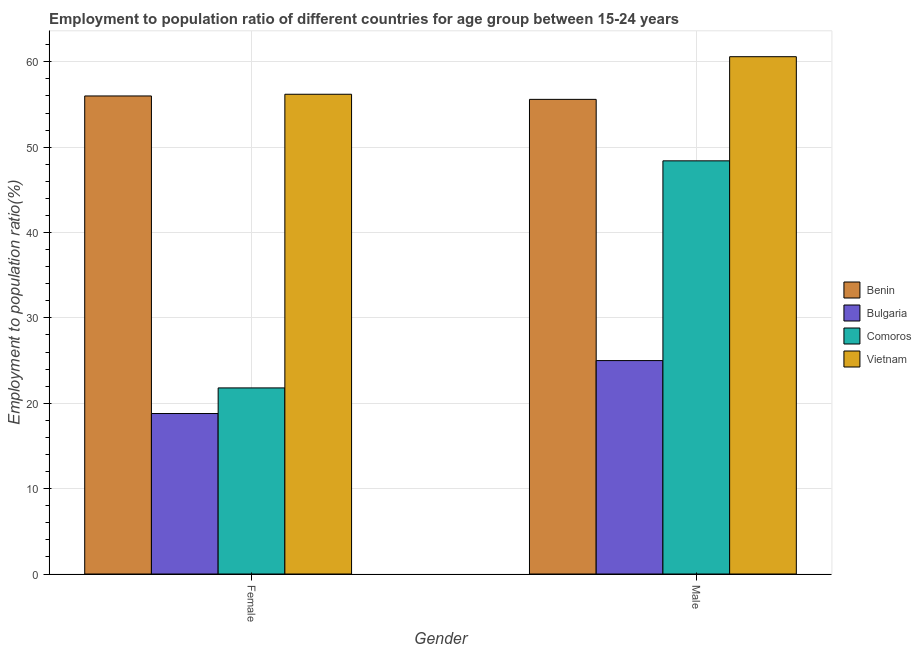How many different coloured bars are there?
Offer a very short reply. 4. How many groups of bars are there?
Your answer should be compact. 2. Are the number of bars per tick equal to the number of legend labels?
Offer a terse response. Yes. Are the number of bars on each tick of the X-axis equal?
Offer a terse response. Yes. How many bars are there on the 2nd tick from the left?
Ensure brevity in your answer.  4. How many bars are there on the 1st tick from the right?
Provide a succinct answer. 4. What is the label of the 2nd group of bars from the left?
Keep it short and to the point. Male. What is the employment to population ratio(male) in Comoros?
Keep it short and to the point. 48.4. Across all countries, what is the maximum employment to population ratio(male)?
Give a very brief answer. 60.6. Across all countries, what is the minimum employment to population ratio(male)?
Offer a terse response. 25. In which country was the employment to population ratio(male) maximum?
Your answer should be compact. Vietnam. In which country was the employment to population ratio(male) minimum?
Provide a short and direct response. Bulgaria. What is the total employment to population ratio(male) in the graph?
Offer a terse response. 189.6. What is the difference between the employment to population ratio(female) in Bulgaria and that in Comoros?
Make the answer very short. -3. What is the difference between the employment to population ratio(male) in Comoros and the employment to population ratio(female) in Vietnam?
Offer a very short reply. -7.8. What is the average employment to population ratio(female) per country?
Give a very brief answer. 38.2. What is the difference between the employment to population ratio(female) and employment to population ratio(male) in Vietnam?
Provide a short and direct response. -4.4. What is the ratio of the employment to population ratio(male) in Comoros to that in Benin?
Provide a succinct answer. 0.87. Is the employment to population ratio(female) in Bulgaria less than that in Comoros?
Offer a terse response. Yes. What does the 3rd bar from the left in Male represents?
Provide a short and direct response. Comoros. What does the 3rd bar from the right in Male represents?
Your answer should be very brief. Bulgaria. What is the difference between two consecutive major ticks on the Y-axis?
Offer a terse response. 10. Does the graph contain any zero values?
Provide a short and direct response. No. Where does the legend appear in the graph?
Ensure brevity in your answer.  Center right. How many legend labels are there?
Make the answer very short. 4. How are the legend labels stacked?
Ensure brevity in your answer.  Vertical. What is the title of the graph?
Ensure brevity in your answer.  Employment to population ratio of different countries for age group between 15-24 years. What is the label or title of the Y-axis?
Keep it short and to the point. Employment to population ratio(%). What is the Employment to population ratio(%) in Benin in Female?
Provide a succinct answer. 56. What is the Employment to population ratio(%) of Bulgaria in Female?
Offer a very short reply. 18.8. What is the Employment to population ratio(%) of Comoros in Female?
Offer a terse response. 21.8. What is the Employment to population ratio(%) in Vietnam in Female?
Provide a short and direct response. 56.2. What is the Employment to population ratio(%) in Benin in Male?
Keep it short and to the point. 55.6. What is the Employment to population ratio(%) in Comoros in Male?
Offer a terse response. 48.4. What is the Employment to population ratio(%) in Vietnam in Male?
Your answer should be very brief. 60.6. Across all Gender, what is the maximum Employment to population ratio(%) of Comoros?
Make the answer very short. 48.4. Across all Gender, what is the maximum Employment to population ratio(%) in Vietnam?
Provide a short and direct response. 60.6. Across all Gender, what is the minimum Employment to population ratio(%) in Benin?
Keep it short and to the point. 55.6. Across all Gender, what is the minimum Employment to population ratio(%) in Bulgaria?
Keep it short and to the point. 18.8. Across all Gender, what is the minimum Employment to population ratio(%) in Comoros?
Your answer should be compact. 21.8. Across all Gender, what is the minimum Employment to population ratio(%) of Vietnam?
Provide a short and direct response. 56.2. What is the total Employment to population ratio(%) in Benin in the graph?
Keep it short and to the point. 111.6. What is the total Employment to population ratio(%) of Bulgaria in the graph?
Keep it short and to the point. 43.8. What is the total Employment to population ratio(%) of Comoros in the graph?
Provide a succinct answer. 70.2. What is the total Employment to population ratio(%) of Vietnam in the graph?
Offer a terse response. 116.8. What is the difference between the Employment to population ratio(%) of Comoros in Female and that in Male?
Ensure brevity in your answer.  -26.6. What is the difference between the Employment to population ratio(%) of Benin in Female and the Employment to population ratio(%) of Bulgaria in Male?
Offer a very short reply. 31. What is the difference between the Employment to population ratio(%) of Bulgaria in Female and the Employment to population ratio(%) of Comoros in Male?
Offer a terse response. -29.6. What is the difference between the Employment to population ratio(%) of Bulgaria in Female and the Employment to population ratio(%) of Vietnam in Male?
Ensure brevity in your answer.  -41.8. What is the difference between the Employment to population ratio(%) of Comoros in Female and the Employment to population ratio(%) of Vietnam in Male?
Keep it short and to the point. -38.8. What is the average Employment to population ratio(%) in Benin per Gender?
Provide a short and direct response. 55.8. What is the average Employment to population ratio(%) of Bulgaria per Gender?
Your answer should be very brief. 21.9. What is the average Employment to population ratio(%) in Comoros per Gender?
Ensure brevity in your answer.  35.1. What is the average Employment to population ratio(%) in Vietnam per Gender?
Keep it short and to the point. 58.4. What is the difference between the Employment to population ratio(%) of Benin and Employment to population ratio(%) of Bulgaria in Female?
Make the answer very short. 37.2. What is the difference between the Employment to population ratio(%) of Benin and Employment to population ratio(%) of Comoros in Female?
Keep it short and to the point. 34.2. What is the difference between the Employment to population ratio(%) in Benin and Employment to population ratio(%) in Vietnam in Female?
Your answer should be compact. -0.2. What is the difference between the Employment to population ratio(%) of Bulgaria and Employment to population ratio(%) of Comoros in Female?
Provide a short and direct response. -3. What is the difference between the Employment to population ratio(%) of Bulgaria and Employment to population ratio(%) of Vietnam in Female?
Your response must be concise. -37.4. What is the difference between the Employment to population ratio(%) of Comoros and Employment to population ratio(%) of Vietnam in Female?
Your answer should be very brief. -34.4. What is the difference between the Employment to population ratio(%) in Benin and Employment to population ratio(%) in Bulgaria in Male?
Offer a terse response. 30.6. What is the difference between the Employment to population ratio(%) in Bulgaria and Employment to population ratio(%) in Comoros in Male?
Your response must be concise. -23.4. What is the difference between the Employment to population ratio(%) in Bulgaria and Employment to population ratio(%) in Vietnam in Male?
Make the answer very short. -35.6. What is the difference between the Employment to population ratio(%) of Comoros and Employment to population ratio(%) of Vietnam in Male?
Provide a short and direct response. -12.2. What is the ratio of the Employment to population ratio(%) of Bulgaria in Female to that in Male?
Keep it short and to the point. 0.75. What is the ratio of the Employment to population ratio(%) in Comoros in Female to that in Male?
Keep it short and to the point. 0.45. What is the ratio of the Employment to population ratio(%) in Vietnam in Female to that in Male?
Ensure brevity in your answer.  0.93. What is the difference between the highest and the second highest Employment to population ratio(%) of Bulgaria?
Make the answer very short. 6.2. What is the difference between the highest and the second highest Employment to population ratio(%) of Comoros?
Keep it short and to the point. 26.6. What is the difference between the highest and the lowest Employment to population ratio(%) in Comoros?
Give a very brief answer. 26.6. What is the difference between the highest and the lowest Employment to population ratio(%) of Vietnam?
Your answer should be very brief. 4.4. 